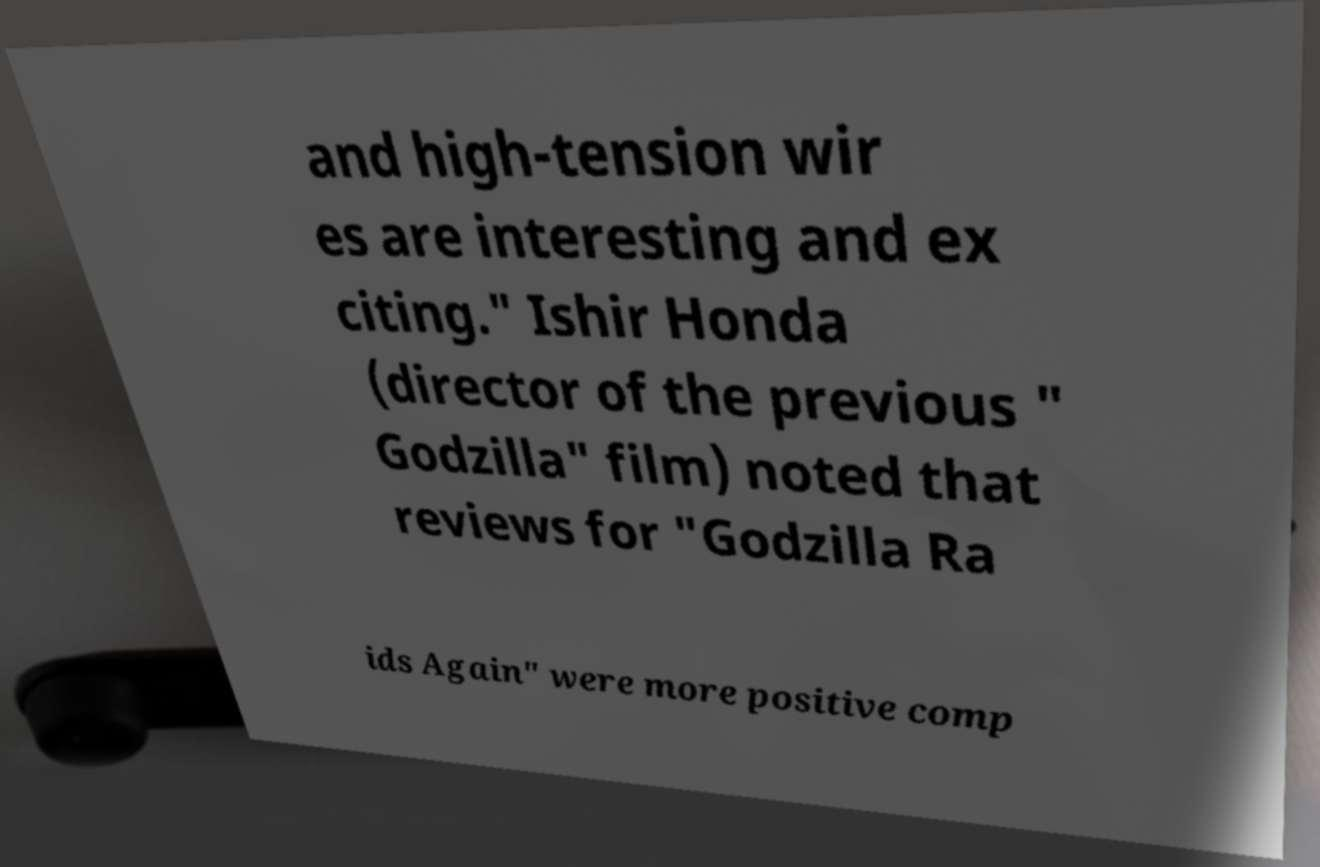For documentation purposes, I need the text within this image transcribed. Could you provide that? and high-tension wir es are interesting and ex citing." Ishir Honda (director of the previous " Godzilla" film) noted that reviews for "Godzilla Ra ids Again" were more positive comp 